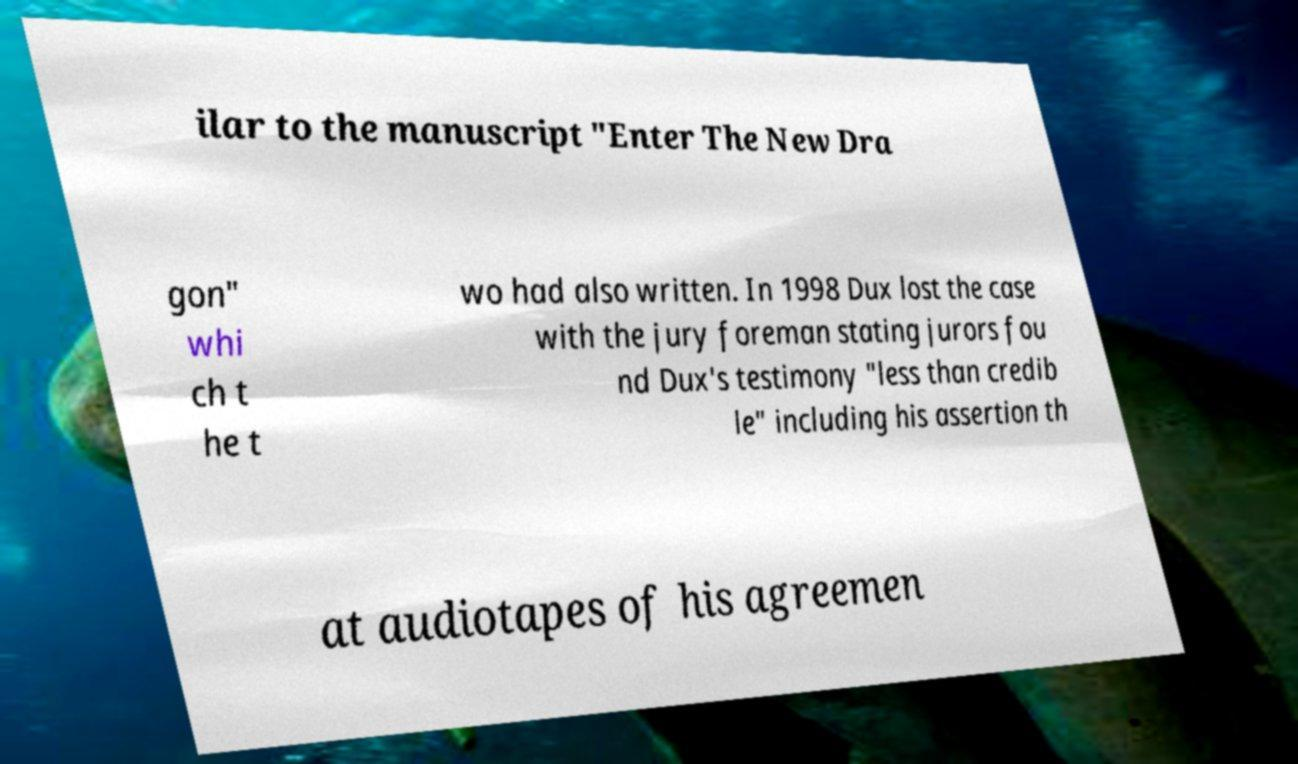Please read and relay the text visible in this image. What does it say? ilar to the manuscript "Enter The New Dra gon" whi ch t he t wo had also written. In 1998 Dux lost the case with the jury foreman stating jurors fou nd Dux's testimony "less than credib le" including his assertion th at audiotapes of his agreemen 